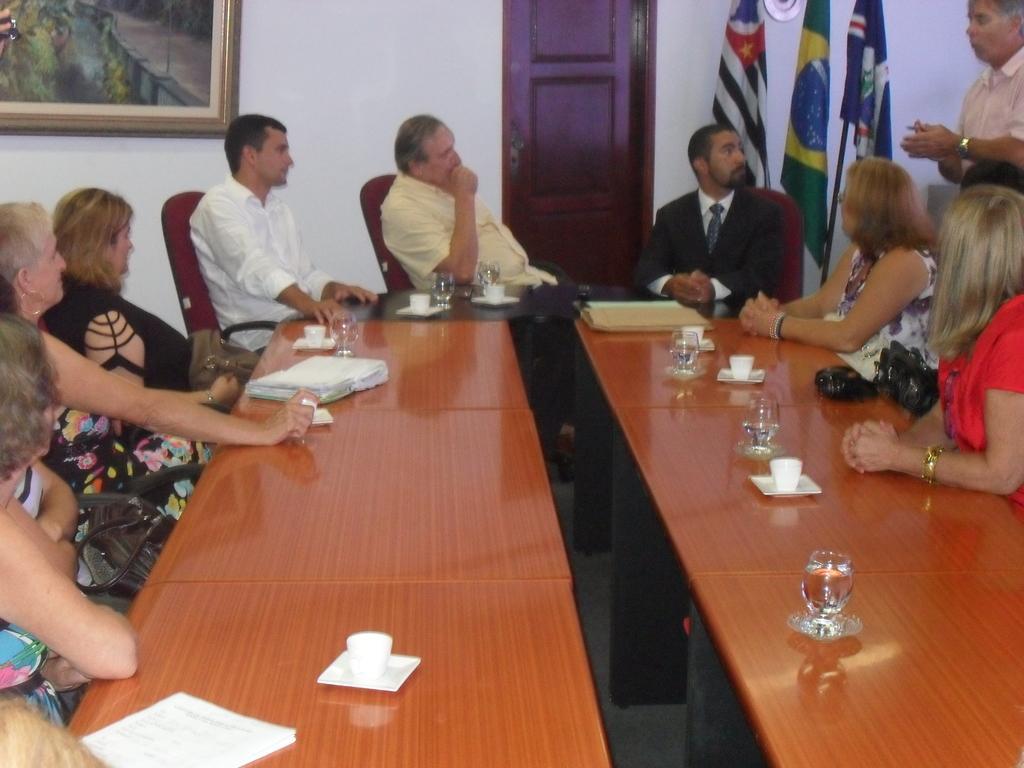Could you give a brief overview of what you see in this image? We can see a frame over a wall. This is a door. We can see three different flags. We can see one man standing and talking. Here w can see all the persons sitting on chairs in front of a table and on the table we can see cups, saucers, water glasses, book, papers. 